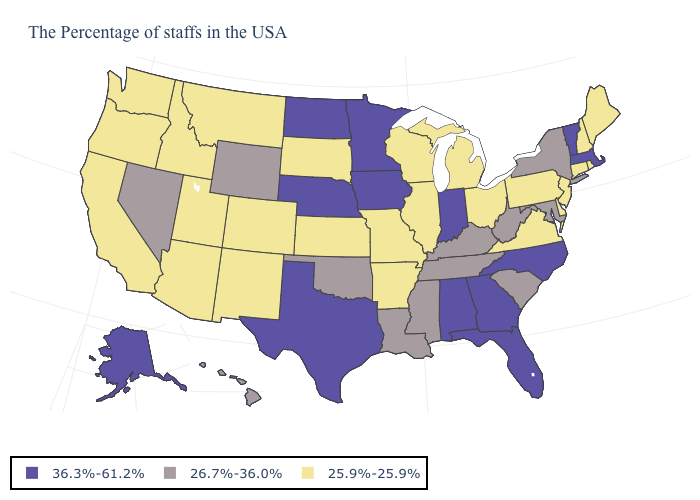What is the value of Vermont?
Quick response, please. 36.3%-61.2%. Name the states that have a value in the range 25.9%-25.9%?
Keep it brief. Maine, Rhode Island, New Hampshire, Connecticut, New Jersey, Delaware, Pennsylvania, Virginia, Ohio, Michigan, Wisconsin, Illinois, Missouri, Arkansas, Kansas, South Dakota, Colorado, New Mexico, Utah, Montana, Arizona, Idaho, California, Washington, Oregon. Name the states that have a value in the range 25.9%-25.9%?
Short answer required. Maine, Rhode Island, New Hampshire, Connecticut, New Jersey, Delaware, Pennsylvania, Virginia, Ohio, Michigan, Wisconsin, Illinois, Missouri, Arkansas, Kansas, South Dakota, Colorado, New Mexico, Utah, Montana, Arizona, Idaho, California, Washington, Oregon. What is the highest value in the USA?
Quick response, please. 36.3%-61.2%. What is the value of Missouri?
Give a very brief answer. 25.9%-25.9%. What is the value of Illinois?
Keep it brief. 25.9%-25.9%. Name the states that have a value in the range 26.7%-36.0%?
Short answer required. New York, Maryland, South Carolina, West Virginia, Kentucky, Tennessee, Mississippi, Louisiana, Oklahoma, Wyoming, Nevada, Hawaii. Name the states that have a value in the range 26.7%-36.0%?
Short answer required. New York, Maryland, South Carolina, West Virginia, Kentucky, Tennessee, Mississippi, Louisiana, Oklahoma, Wyoming, Nevada, Hawaii. Which states have the highest value in the USA?
Be succinct. Massachusetts, Vermont, North Carolina, Florida, Georgia, Indiana, Alabama, Minnesota, Iowa, Nebraska, Texas, North Dakota, Alaska. What is the value of Alabama?
Give a very brief answer. 36.3%-61.2%. What is the highest value in the South ?
Concise answer only. 36.3%-61.2%. Does Iowa have the lowest value in the MidWest?
Concise answer only. No. Name the states that have a value in the range 36.3%-61.2%?
Quick response, please. Massachusetts, Vermont, North Carolina, Florida, Georgia, Indiana, Alabama, Minnesota, Iowa, Nebraska, Texas, North Dakota, Alaska. What is the lowest value in states that border Mississippi?
Concise answer only. 25.9%-25.9%. 